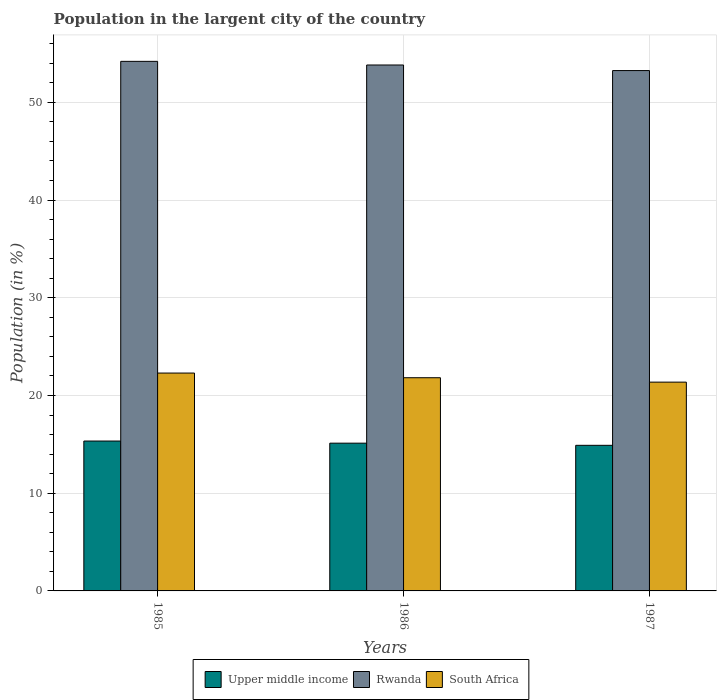How many different coloured bars are there?
Offer a terse response. 3. Are the number of bars per tick equal to the number of legend labels?
Keep it short and to the point. Yes. Are the number of bars on each tick of the X-axis equal?
Keep it short and to the point. Yes. How many bars are there on the 1st tick from the left?
Your answer should be compact. 3. How many bars are there on the 3rd tick from the right?
Offer a very short reply. 3. What is the label of the 1st group of bars from the left?
Give a very brief answer. 1985. What is the percentage of population in the largent city in Upper middle income in 1986?
Your response must be concise. 15.12. Across all years, what is the maximum percentage of population in the largent city in Rwanda?
Offer a very short reply. 54.19. Across all years, what is the minimum percentage of population in the largent city in Rwanda?
Offer a very short reply. 53.25. In which year was the percentage of population in the largent city in South Africa minimum?
Your answer should be compact. 1987. What is the total percentage of population in the largent city in Upper middle income in the graph?
Ensure brevity in your answer.  45.36. What is the difference between the percentage of population in the largent city in Upper middle income in 1985 and that in 1986?
Provide a short and direct response. 0.22. What is the difference between the percentage of population in the largent city in Upper middle income in 1986 and the percentage of population in the largent city in Rwanda in 1987?
Provide a short and direct response. -38.13. What is the average percentage of population in the largent city in Upper middle income per year?
Make the answer very short. 15.12. In the year 1987, what is the difference between the percentage of population in the largent city in South Africa and percentage of population in the largent city in Upper middle income?
Offer a terse response. 6.47. What is the ratio of the percentage of population in the largent city in Upper middle income in 1985 to that in 1986?
Keep it short and to the point. 1.01. Is the difference between the percentage of population in the largent city in South Africa in 1986 and 1987 greater than the difference between the percentage of population in the largent city in Upper middle income in 1986 and 1987?
Provide a succinct answer. Yes. What is the difference between the highest and the second highest percentage of population in the largent city in South Africa?
Your answer should be very brief. 0.48. What is the difference between the highest and the lowest percentage of population in the largent city in Upper middle income?
Provide a succinct answer. 0.44. What does the 3rd bar from the left in 1985 represents?
Give a very brief answer. South Africa. What does the 2nd bar from the right in 1986 represents?
Offer a terse response. Rwanda. Is it the case that in every year, the sum of the percentage of population in the largent city in Rwanda and percentage of population in the largent city in Upper middle income is greater than the percentage of population in the largent city in South Africa?
Provide a succinct answer. Yes. How many years are there in the graph?
Ensure brevity in your answer.  3. Does the graph contain grids?
Provide a succinct answer. Yes. How are the legend labels stacked?
Your answer should be very brief. Horizontal. What is the title of the graph?
Provide a succinct answer. Population in the largent city of the country. What is the label or title of the X-axis?
Provide a succinct answer. Years. What is the label or title of the Y-axis?
Your answer should be compact. Population (in %). What is the Population (in %) in Upper middle income in 1985?
Offer a terse response. 15.34. What is the Population (in %) of Rwanda in 1985?
Provide a succinct answer. 54.19. What is the Population (in %) in South Africa in 1985?
Make the answer very short. 22.29. What is the Population (in %) of Upper middle income in 1986?
Your answer should be compact. 15.12. What is the Population (in %) of Rwanda in 1986?
Make the answer very short. 53.82. What is the Population (in %) of South Africa in 1986?
Ensure brevity in your answer.  21.82. What is the Population (in %) of Upper middle income in 1987?
Your answer should be very brief. 14.9. What is the Population (in %) in Rwanda in 1987?
Ensure brevity in your answer.  53.25. What is the Population (in %) of South Africa in 1987?
Provide a short and direct response. 21.36. Across all years, what is the maximum Population (in %) of Upper middle income?
Ensure brevity in your answer.  15.34. Across all years, what is the maximum Population (in %) of Rwanda?
Make the answer very short. 54.19. Across all years, what is the maximum Population (in %) of South Africa?
Make the answer very short. 22.29. Across all years, what is the minimum Population (in %) of Upper middle income?
Offer a terse response. 14.9. Across all years, what is the minimum Population (in %) in Rwanda?
Your answer should be very brief. 53.25. Across all years, what is the minimum Population (in %) of South Africa?
Your response must be concise. 21.36. What is the total Population (in %) of Upper middle income in the graph?
Give a very brief answer. 45.36. What is the total Population (in %) in Rwanda in the graph?
Offer a terse response. 161.25. What is the total Population (in %) in South Africa in the graph?
Make the answer very short. 65.47. What is the difference between the Population (in %) in Upper middle income in 1985 and that in 1986?
Keep it short and to the point. 0.22. What is the difference between the Population (in %) of Rwanda in 1985 and that in 1986?
Ensure brevity in your answer.  0.37. What is the difference between the Population (in %) of South Africa in 1985 and that in 1986?
Give a very brief answer. 0.48. What is the difference between the Population (in %) in Upper middle income in 1985 and that in 1987?
Offer a very short reply. 0.44. What is the difference between the Population (in %) in Rwanda in 1985 and that in 1987?
Your answer should be very brief. 0.94. What is the difference between the Population (in %) in South Africa in 1985 and that in 1987?
Make the answer very short. 0.93. What is the difference between the Population (in %) of Upper middle income in 1986 and that in 1987?
Offer a terse response. 0.22. What is the difference between the Population (in %) of Rwanda in 1986 and that in 1987?
Give a very brief answer. 0.57. What is the difference between the Population (in %) of South Africa in 1986 and that in 1987?
Provide a short and direct response. 0.45. What is the difference between the Population (in %) in Upper middle income in 1985 and the Population (in %) in Rwanda in 1986?
Make the answer very short. -38.48. What is the difference between the Population (in %) of Upper middle income in 1985 and the Population (in %) of South Africa in 1986?
Your response must be concise. -6.48. What is the difference between the Population (in %) of Rwanda in 1985 and the Population (in %) of South Africa in 1986?
Ensure brevity in your answer.  32.37. What is the difference between the Population (in %) of Upper middle income in 1985 and the Population (in %) of Rwanda in 1987?
Keep it short and to the point. -37.91. What is the difference between the Population (in %) of Upper middle income in 1985 and the Population (in %) of South Africa in 1987?
Your answer should be very brief. -6.03. What is the difference between the Population (in %) in Rwanda in 1985 and the Population (in %) in South Africa in 1987?
Make the answer very short. 32.82. What is the difference between the Population (in %) in Upper middle income in 1986 and the Population (in %) in Rwanda in 1987?
Make the answer very short. -38.13. What is the difference between the Population (in %) of Upper middle income in 1986 and the Population (in %) of South Africa in 1987?
Keep it short and to the point. -6.25. What is the difference between the Population (in %) of Rwanda in 1986 and the Population (in %) of South Africa in 1987?
Offer a terse response. 32.45. What is the average Population (in %) of Upper middle income per year?
Offer a terse response. 15.12. What is the average Population (in %) in Rwanda per year?
Keep it short and to the point. 53.75. What is the average Population (in %) in South Africa per year?
Your answer should be compact. 21.82. In the year 1985, what is the difference between the Population (in %) in Upper middle income and Population (in %) in Rwanda?
Provide a short and direct response. -38.85. In the year 1985, what is the difference between the Population (in %) in Upper middle income and Population (in %) in South Africa?
Your response must be concise. -6.96. In the year 1985, what is the difference between the Population (in %) of Rwanda and Population (in %) of South Africa?
Offer a terse response. 31.89. In the year 1986, what is the difference between the Population (in %) of Upper middle income and Population (in %) of Rwanda?
Ensure brevity in your answer.  -38.7. In the year 1986, what is the difference between the Population (in %) in Upper middle income and Population (in %) in South Africa?
Your answer should be very brief. -6.7. In the year 1986, what is the difference between the Population (in %) of Rwanda and Population (in %) of South Africa?
Provide a succinct answer. 32. In the year 1987, what is the difference between the Population (in %) of Upper middle income and Population (in %) of Rwanda?
Give a very brief answer. -38.35. In the year 1987, what is the difference between the Population (in %) in Upper middle income and Population (in %) in South Africa?
Make the answer very short. -6.47. In the year 1987, what is the difference between the Population (in %) of Rwanda and Population (in %) of South Africa?
Your answer should be very brief. 31.88. What is the ratio of the Population (in %) of Upper middle income in 1985 to that in 1986?
Give a very brief answer. 1.01. What is the ratio of the Population (in %) in Rwanda in 1985 to that in 1986?
Offer a very short reply. 1.01. What is the ratio of the Population (in %) in South Africa in 1985 to that in 1986?
Offer a terse response. 1.02. What is the ratio of the Population (in %) of Upper middle income in 1985 to that in 1987?
Provide a short and direct response. 1.03. What is the ratio of the Population (in %) in Rwanda in 1985 to that in 1987?
Offer a very short reply. 1.02. What is the ratio of the Population (in %) in South Africa in 1985 to that in 1987?
Ensure brevity in your answer.  1.04. What is the ratio of the Population (in %) of Upper middle income in 1986 to that in 1987?
Your answer should be very brief. 1.01. What is the ratio of the Population (in %) in Rwanda in 1986 to that in 1987?
Give a very brief answer. 1.01. What is the ratio of the Population (in %) of South Africa in 1986 to that in 1987?
Offer a very short reply. 1.02. What is the difference between the highest and the second highest Population (in %) in Upper middle income?
Offer a very short reply. 0.22. What is the difference between the highest and the second highest Population (in %) of Rwanda?
Your answer should be very brief. 0.37. What is the difference between the highest and the second highest Population (in %) in South Africa?
Provide a succinct answer. 0.48. What is the difference between the highest and the lowest Population (in %) in Upper middle income?
Your response must be concise. 0.44. What is the difference between the highest and the lowest Population (in %) of Rwanda?
Your answer should be very brief. 0.94. What is the difference between the highest and the lowest Population (in %) in South Africa?
Keep it short and to the point. 0.93. 